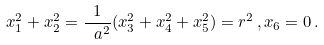Convert formula to latex. <formula><loc_0><loc_0><loc_500><loc_500>x _ { 1 } ^ { 2 } + x _ { 2 } ^ { 2 } = \frac { 1 } { \ a ^ { 2 } } ( x _ { 3 } ^ { 2 } + x _ { 4 } ^ { 2 } + x _ { 5 } ^ { 2 } ) = r ^ { 2 } \, , x _ { 6 } = 0 \, .</formula> 